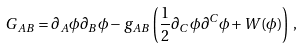<formula> <loc_0><loc_0><loc_500><loc_500>G _ { A B } = \partial _ { A } \phi \partial _ { B } \phi - g _ { A B } \left ( \frac { 1 } { 2 } \partial _ { C } \, \phi \partial ^ { C } \phi + W ( \phi ) \right ) \, ,</formula> 